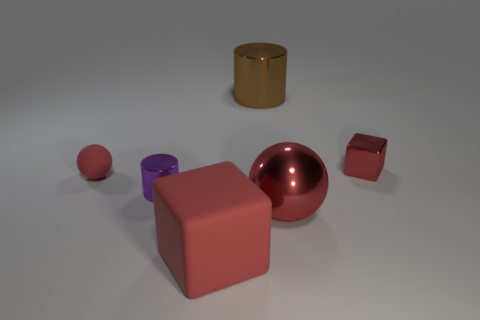Add 1 red metallic balls. How many objects exist? 7 Subtract all cubes. How many objects are left? 4 Subtract all large brown metal objects. Subtract all metallic cubes. How many objects are left? 4 Add 3 red matte objects. How many red matte objects are left? 5 Add 6 small things. How many small things exist? 9 Subtract 0 cyan balls. How many objects are left? 6 